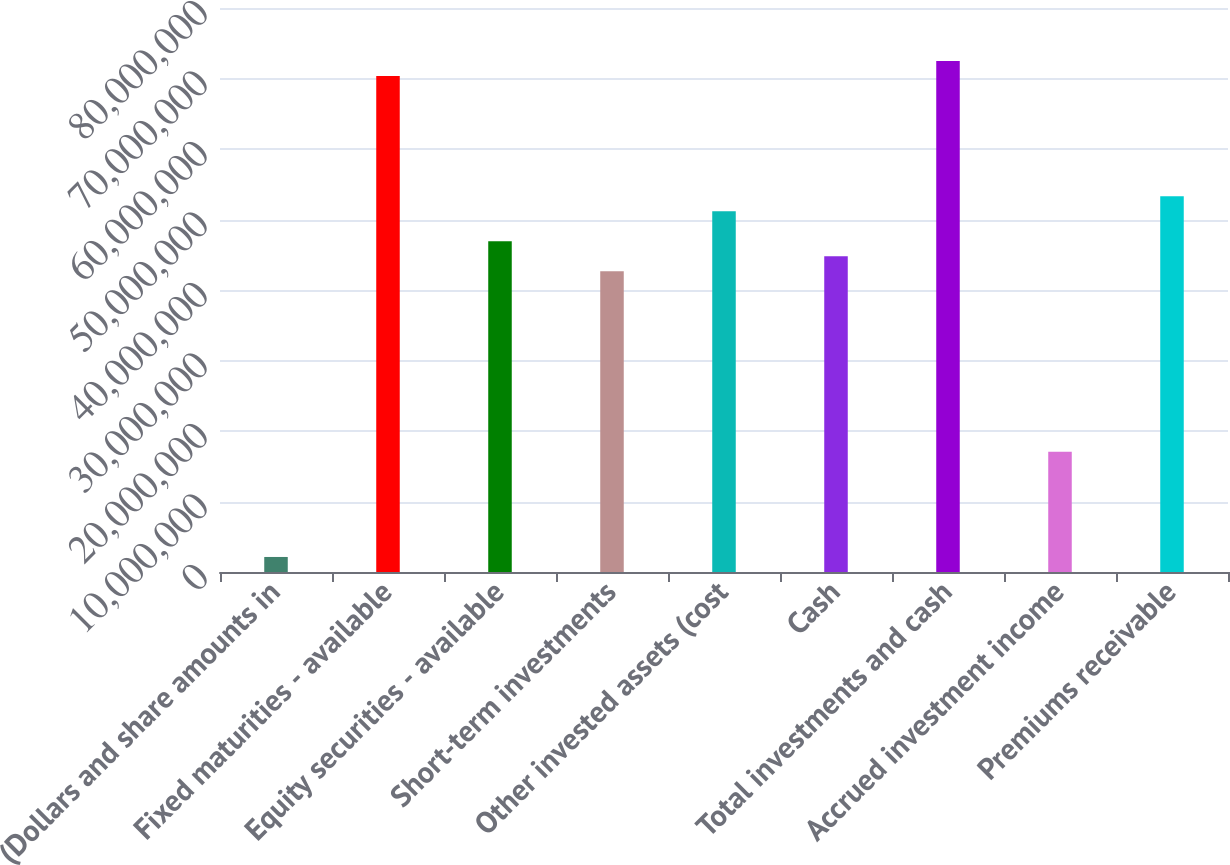<chart> <loc_0><loc_0><loc_500><loc_500><bar_chart><fcel>(Dollars and share amounts in<fcel>Fixed maturities - available<fcel>Equity securities - available<fcel>Short-term investments<fcel>Other invested assets (cost<fcel>Cash<fcel>Total investments and cash<fcel>Accrued investment income<fcel>Premiums receivable<nl><fcel>2.13277e+06<fcel>7.03594e+07<fcel>4.69065e+07<fcel>4.26423e+07<fcel>5.11706e+07<fcel>4.47744e+07<fcel>7.24915e+07<fcel>1.70573e+07<fcel>5.33027e+07<nl></chart> 